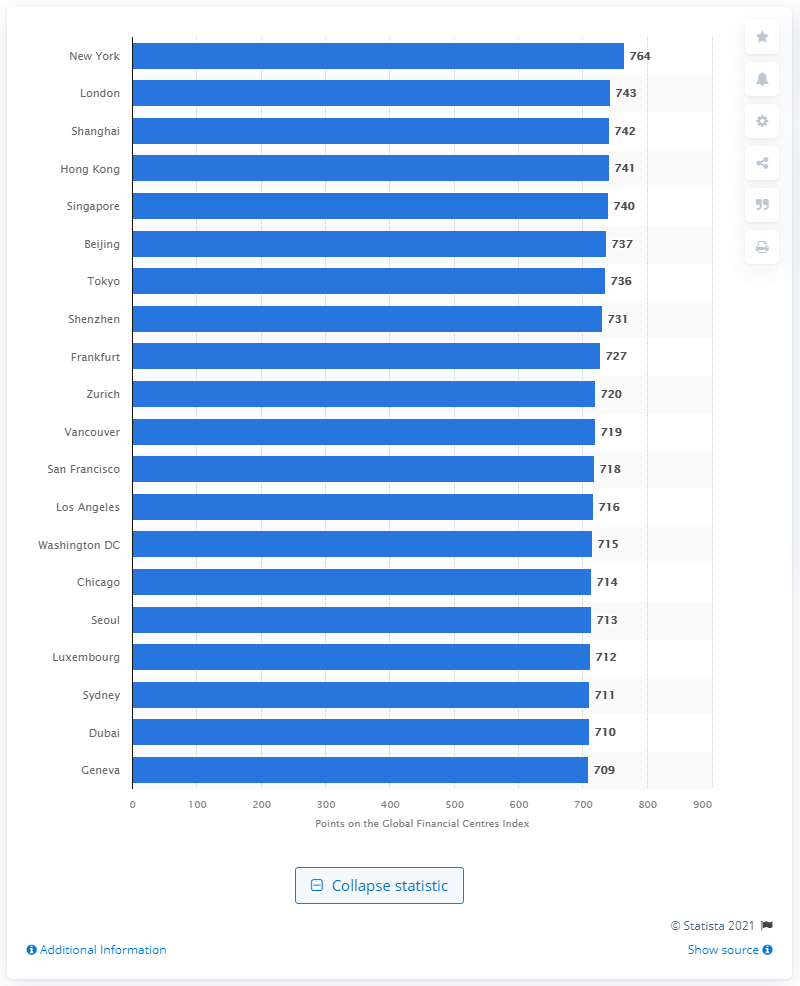Give some essential details in this illustration. On March 1st, 2021, the rating of New York was 764. In March 2021, London's rating was 743. 